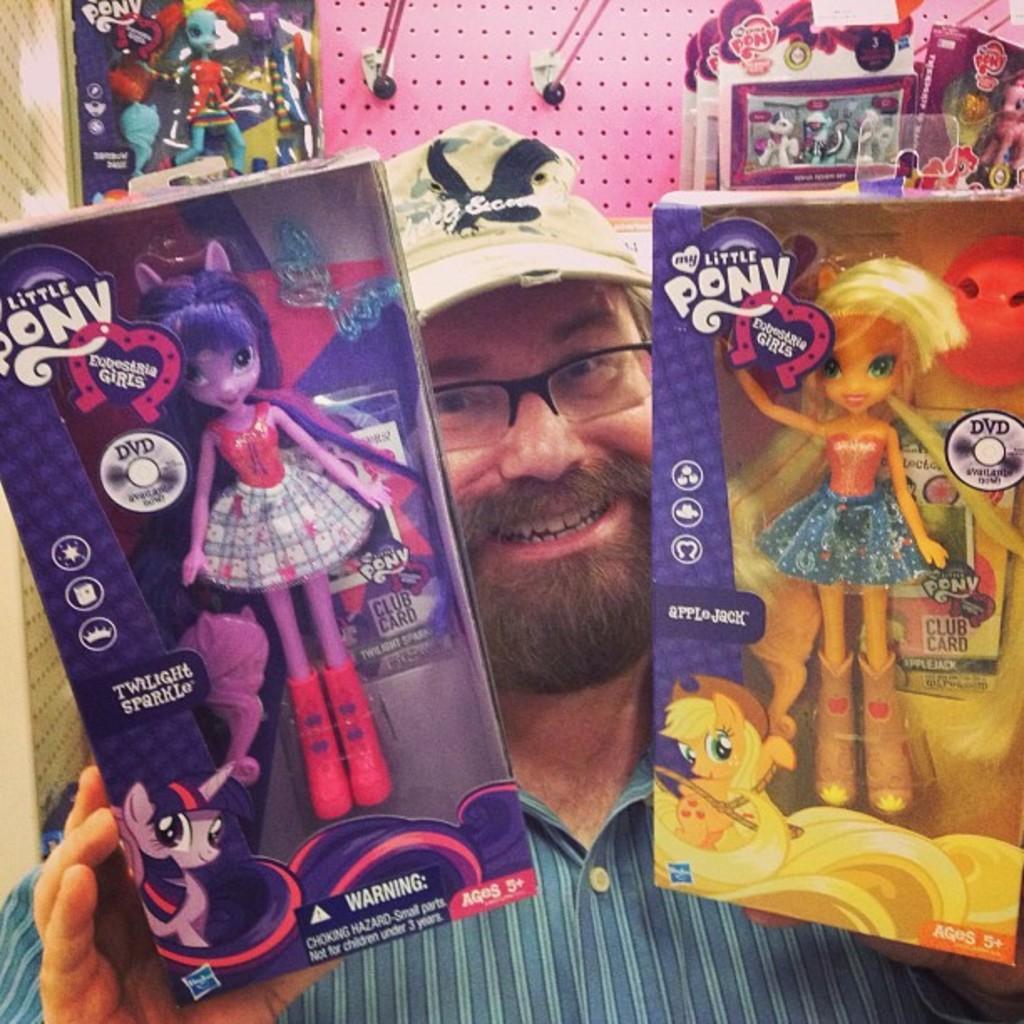Describe this image in one or two sentences. In this image there is a person holding two toys with the both of the hands with a smile on his face, behind him there are few more toys arranged in a rack. 